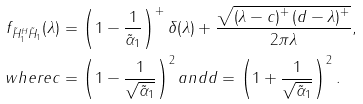Convert formula to latex. <formula><loc_0><loc_0><loc_500><loc_500>f _ { \tilde { H } _ { 1 } ^ { H } \tilde { H } _ { 1 } } ( \lambda ) & = \left ( 1 - \frac { 1 } { \tilde { \alpha } _ { 1 } } \right ) ^ { + } \delta ( \lambda ) + \frac { \sqrt { \left ( \lambda - c \right ) ^ { + } \left ( d - \lambda \right ) ^ { + } } } { 2 \pi \lambda } , \\ w h e r e c & = \left ( 1 - \frac { 1 } { \sqrt { \tilde { \alpha } _ { 1 } } } \right ) ^ { 2 } a n d d = \left ( 1 + \frac { 1 } { \sqrt { \tilde { \alpha } _ { 1 } } } \right ) ^ { 2 } .</formula> 